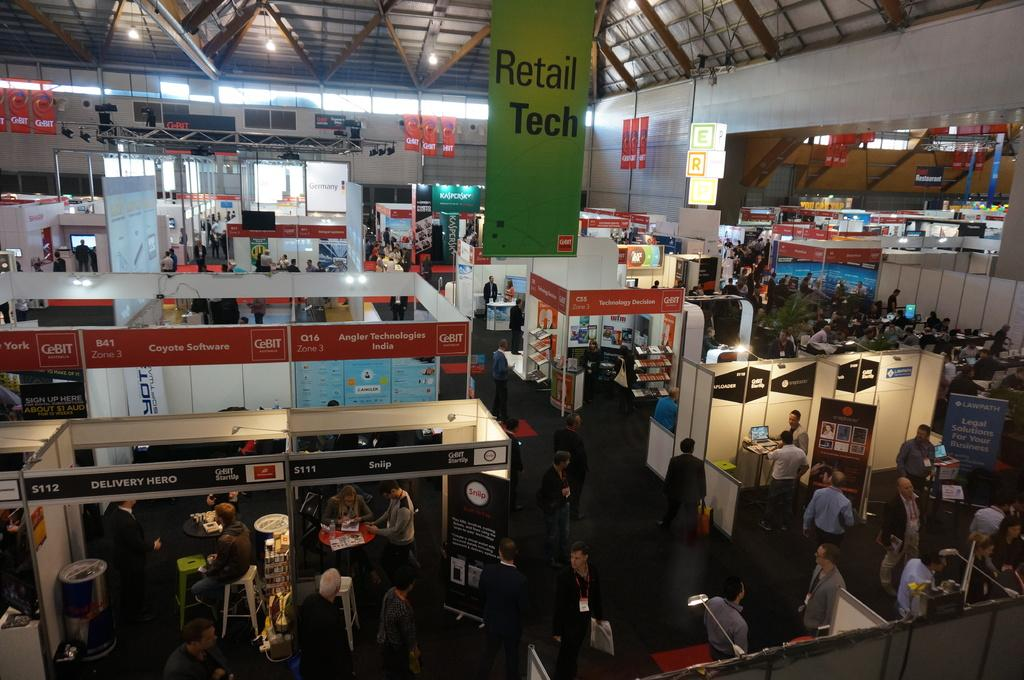How many people can be seen in the image? There are persons in the image, but the exact number is not specified. What type of establishments are present in the image? There are stores in the image. What type of furniture is visible in the image? Chairs and tables are visible in the image. What type of electronic devices are present in the image? Computers are visible in the image. What type of promotional materials are present in the image? Advertisements are present in the image. What type of temporary structures are visible in the image? Tents are visible in the image. What type of illumination is present in the image? Lights are present in the image. What type of architectural feature is present in the image? There is a wall in the image. What type of string is being used to hold the pies in the image? There are no pies present in the image, so there is no string being used to hold them. 